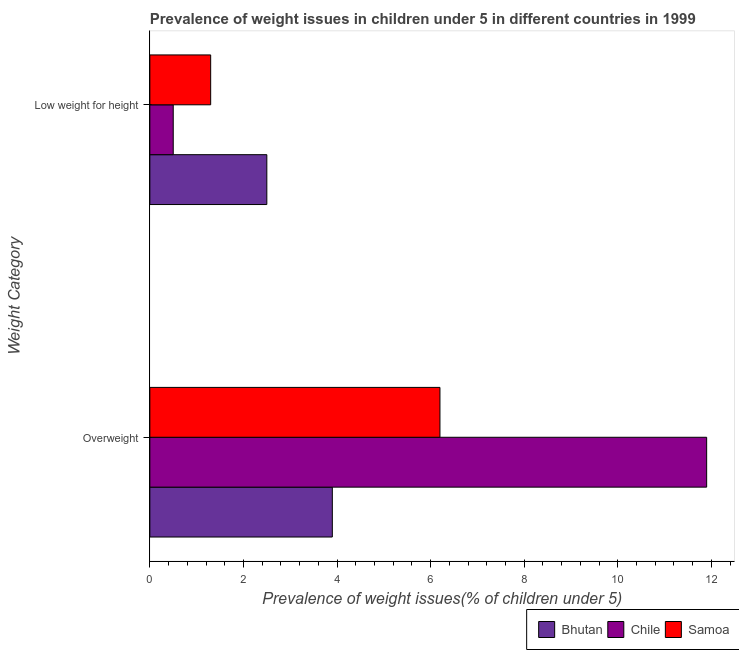How many different coloured bars are there?
Offer a terse response. 3. Are the number of bars per tick equal to the number of legend labels?
Offer a terse response. Yes. Are the number of bars on each tick of the Y-axis equal?
Your answer should be very brief. Yes. How many bars are there on the 1st tick from the top?
Your answer should be very brief. 3. What is the label of the 1st group of bars from the top?
Offer a very short reply. Low weight for height. What is the percentage of overweight children in Bhutan?
Give a very brief answer. 3.9. Across all countries, what is the maximum percentage of overweight children?
Offer a very short reply. 11.9. In which country was the percentage of underweight children maximum?
Offer a very short reply. Bhutan. In which country was the percentage of underweight children minimum?
Give a very brief answer. Chile. What is the total percentage of overweight children in the graph?
Your response must be concise. 22. What is the difference between the percentage of overweight children in Bhutan and that in Chile?
Offer a terse response. -8. What is the difference between the percentage of overweight children in Bhutan and the percentage of underweight children in Samoa?
Provide a succinct answer. 2.6. What is the average percentage of overweight children per country?
Ensure brevity in your answer.  7.33. What is the difference between the percentage of overweight children and percentage of underweight children in Samoa?
Provide a succinct answer. 4.9. What is the ratio of the percentage of overweight children in Samoa to that in Chile?
Your response must be concise. 0.52. Is the percentage of overweight children in Chile less than that in Bhutan?
Provide a short and direct response. No. What does the 2nd bar from the top in Low weight for height represents?
Provide a succinct answer. Chile. What does the 3rd bar from the bottom in Low weight for height represents?
Provide a succinct answer. Samoa. Are all the bars in the graph horizontal?
Your response must be concise. Yes. How many countries are there in the graph?
Ensure brevity in your answer.  3. What is the difference between two consecutive major ticks on the X-axis?
Ensure brevity in your answer.  2. Are the values on the major ticks of X-axis written in scientific E-notation?
Your response must be concise. No. Does the graph contain any zero values?
Make the answer very short. No. Where does the legend appear in the graph?
Offer a very short reply. Bottom right. How many legend labels are there?
Your response must be concise. 3. How are the legend labels stacked?
Offer a very short reply. Horizontal. What is the title of the graph?
Make the answer very short. Prevalence of weight issues in children under 5 in different countries in 1999. What is the label or title of the X-axis?
Keep it short and to the point. Prevalence of weight issues(% of children under 5). What is the label or title of the Y-axis?
Offer a very short reply. Weight Category. What is the Prevalence of weight issues(% of children under 5) of Bhutan in Overweight?
Ensure brevity in your answer.  3.9. What is the Prevalence of weight issues(% of children under 5) in Chile in Overweight?
Ensure brevity in your answer.  11.9. What is the Prevalence of weight issues(% of children under 5) of Samoa in Overweight?
Your answer should be very brief. 6.2. What is the Prevalence of weight issues(% of children under 5) of Samoa in Low weight for height?
Give a very brief answer. 1.3. Across all Weight Category, what is the maximum Prevalence of weight issues(% of children under 5) of Bhutan?
Offer a very short reply. 3.9. Across all Weight Category, what is the maximum Prevalence of weight issues(% of children under 5) of Chile?
Provide a succinct answer. 11.9. Across all Weight Category, what is the maximum Prevalence of weight issues(% of children under 5) in Samoa?
Provide a succinct answer. 6.2. Across all Weight Category, what is the minimum Prevalence of weight issues(% of children under 5) in Samoa?
Your answer should be very brief. 1.3. What is the total Prevalence of weight issues(% of children under 5) of Bhutan in the graph?
Make the answer very short. 6.4. What is the total Prevalence of weight issues(% of children under 5) of Chile in the graph?
Provide a succinct answer. 12.4. What is the difference between the Prevalence of weight issues(% of children under 5) in Chile in Overweight and that in Low weight for height?
Make the answer very short. 11.4. What is the average Prevalence of weight issues(% of children under 5) in Chile per Weight Category?
Keep it short and to the point. 6.2. What is the average Prevalence of weight issues(% of children under 5) in Samoa per Weight Category?
Make the answer very short. 3.75. What is the difference between the Prevalence of weight issues(% of children under 5) in Bhutan and Prevalence of weight issues(% of children under 5) in Chile in Overweight?
Provide a short and direct response. -8. What is the difference between the Prevalence of weight issues(% of children under 5) of Bhutan and Prevalence of weight issues(% of children under 5) of Samoa in Overweight?
Give a very brief answer. -2.3. What is the difference between the Prevalence of weight issues(% of children under 5) of Chile and Prevalence of weight issues(% of children under 5) of Samoa in Overweight?
Provide a short and direct response. 5.7. What is the difference between the Prevalence of weight issues(% of children under 5) of Bhutan and Prevalence of weight issues(% of children under 5) of Samoa in Low weight for height?
Provide a succinct answer. 1.2. What is the ratio of the Prevalence of weight issues(% of children under 5) of Bhutan in Overweight to that in Low weight for height?
Offer a terse response. 1.56. What is the ratio of the Prevalence of weight issues(% of children under 5) in Chile in Overweight to that in Low weight for height?
Your answer should be very brief. 23.8. What is the ratio of the Prevalence of weight issues(% of children under 5) in Samoa in Overweight to that in Low weight for height?
Give a very brief answer. 4.77. What is the difference between the highest and the second highest Prevalence of weight issues(% of children under 5) in Bhutan?
Your answer should be very brief. 1.4. What is the difference between the highest and the second highest Prevalence of weight issues(% of children under 5) of Samoa?
Give a very brief answer. 4.9. What is the difference between the highest and the lowest Prevalence of weight issues(% of children under 5) in Samoa?
Ensure brevity in your answer.  4.9. 